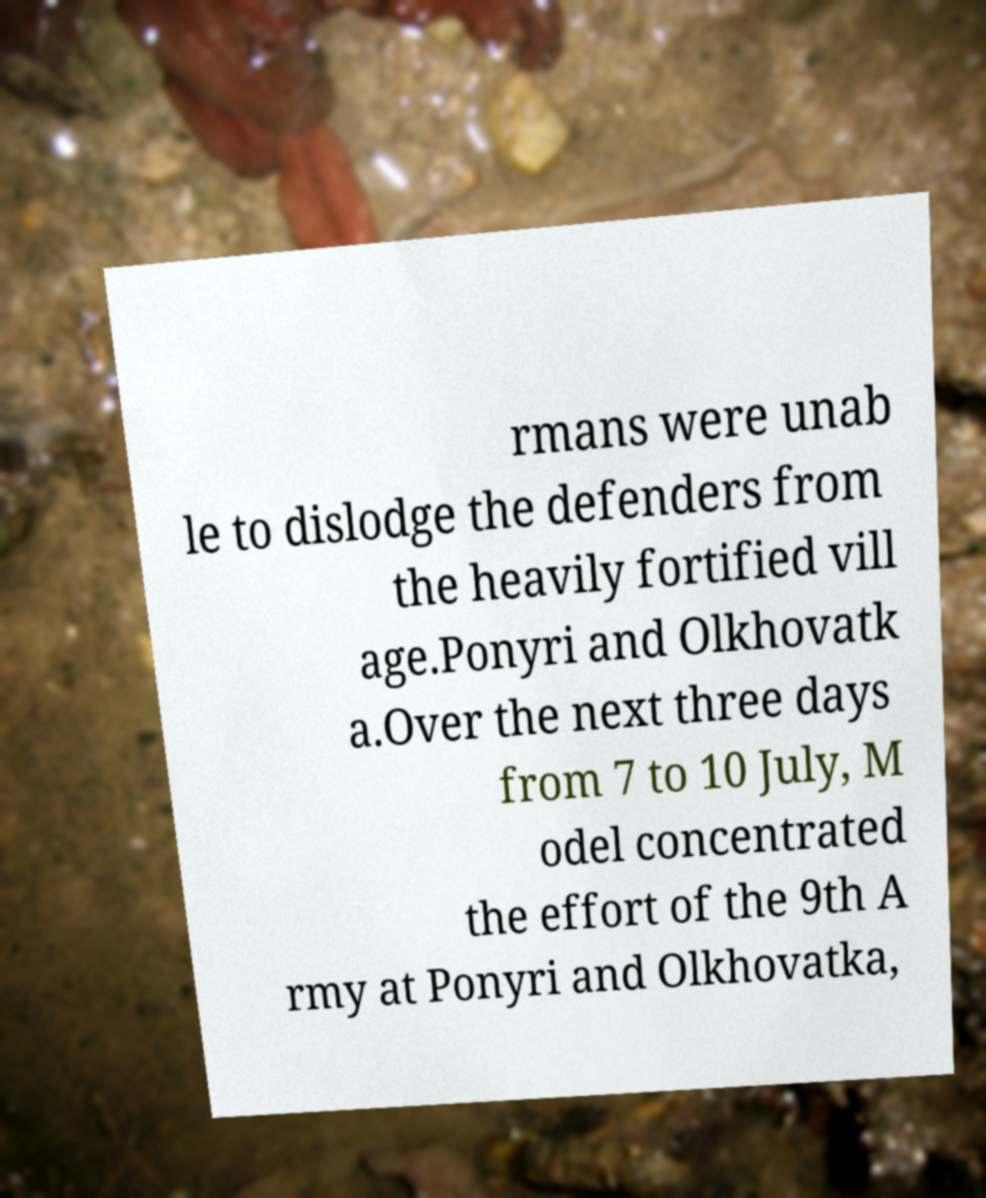Could you extract and type out the text from this image? rmans were unab le to dislodge the defenders from the heavily fortified vill age.Ponyri and Olkhovatk a.Over the next three days from 7 to 10 July, M odel concentrated the effort of the 9th A rmy at Ponyri and Olkhovatka, 